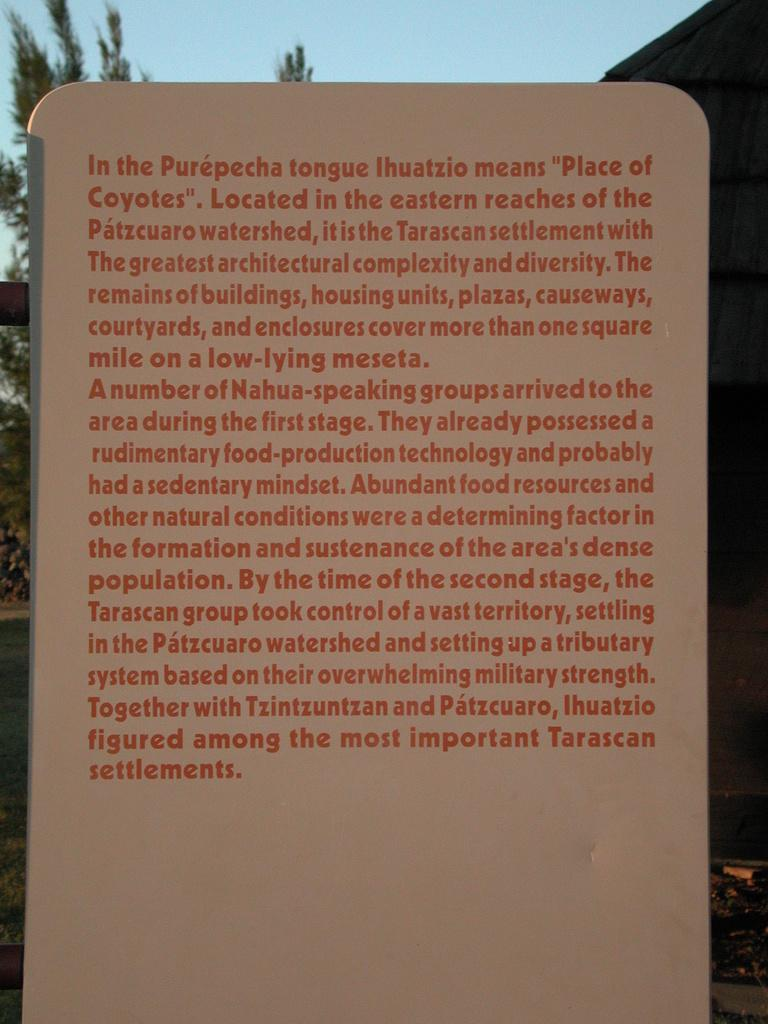What is the main object in the image? There is a board in the image. What is featured on the board? There is writing on the board. Can you see a volleyball game being played on the board in the image? There is no volleyball game or any reference to a volleyball game on the board in the image. What type of line is drawn on the board in the image? There is no line mentioned or visible on the board in the image. 